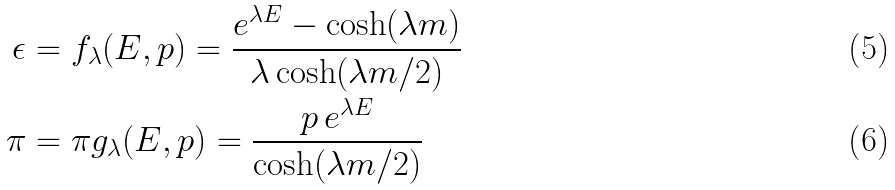<formula> <loc_0><loc_0><loc_500><loc_500>\epsilon & = f _ { \lambda } ( E , p ) = \frac { e ^ { \lambda E } - \cosh ( \lambda m ) } { \lambda \cosh ( \lambda m / 2 ) } \\ \pi & = \pi g _ { \lambda } ( E , p ) = \frac { p \, e ^ { \lambda E } } { \cosh ( \lambda m / 2 ) }</formula> 